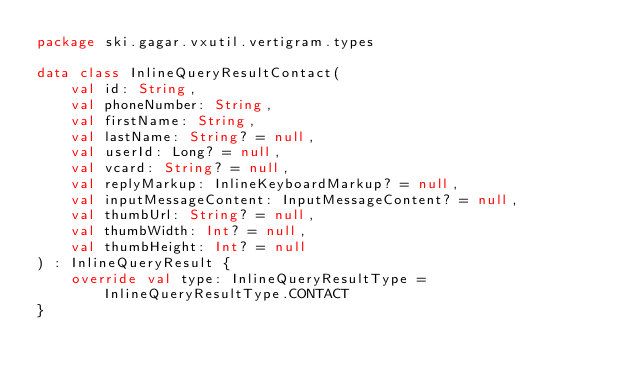Convert code to text. <code><loc_0><loc_0><loc_500><loc_500><_Kotlin_>package ski.gagar.vxutil.vertigram.types

data class InlineQueryResultContact(
    val id: String,
    val phoneNumber: String,
    val firstName: String,
    val lastName: String? = null,
    val userId: Long? = null,
    val vcard: String? = null,
    val replyMarkup: InlineKeyboardMarkup? = null,
    val inputMessageContent: InputMessageContent? = null,
    val thumbUrl: String? = null,
    val thumbWidth: Int? = null,
    val thumbHeight: Int? = null
) : InlineQueryResult {
    override val type: InlineQueryResultType = InlineQueryResultType.CONTACT
}
</code> 